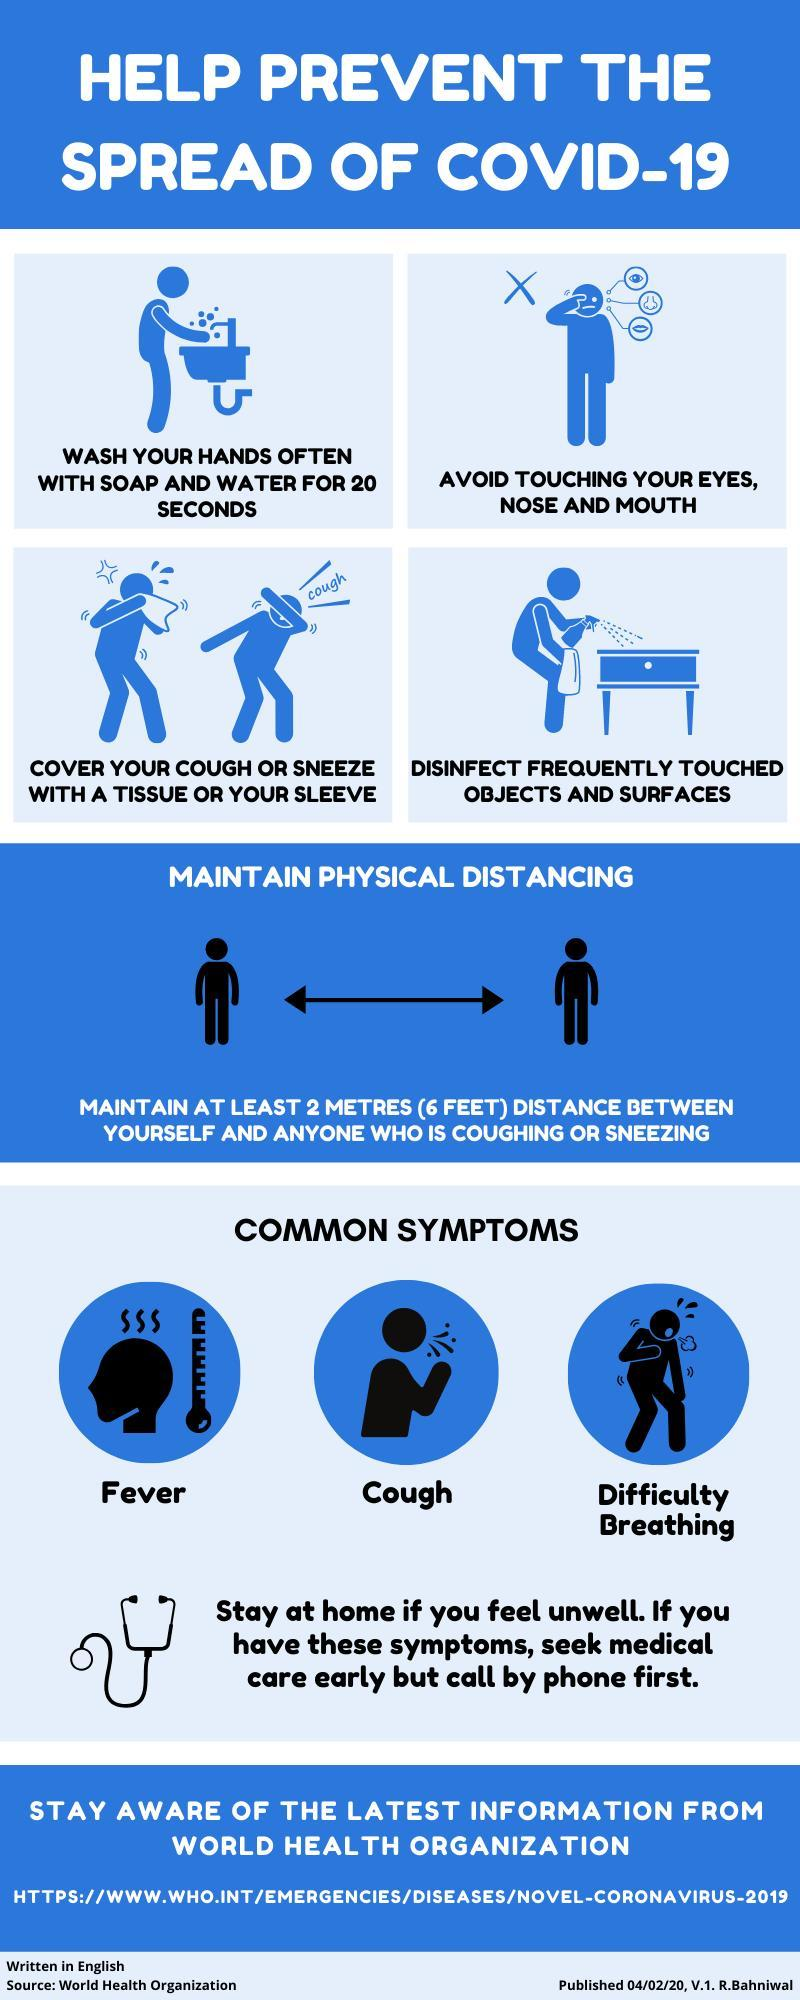What is the common symptom of COVID-19 other than fever & cough?
Answer the question with a short phrase. Difficulty Breathing How long one should wash their hands in order to prevent the spread of COVID-19? FOR 20 SECONDS 